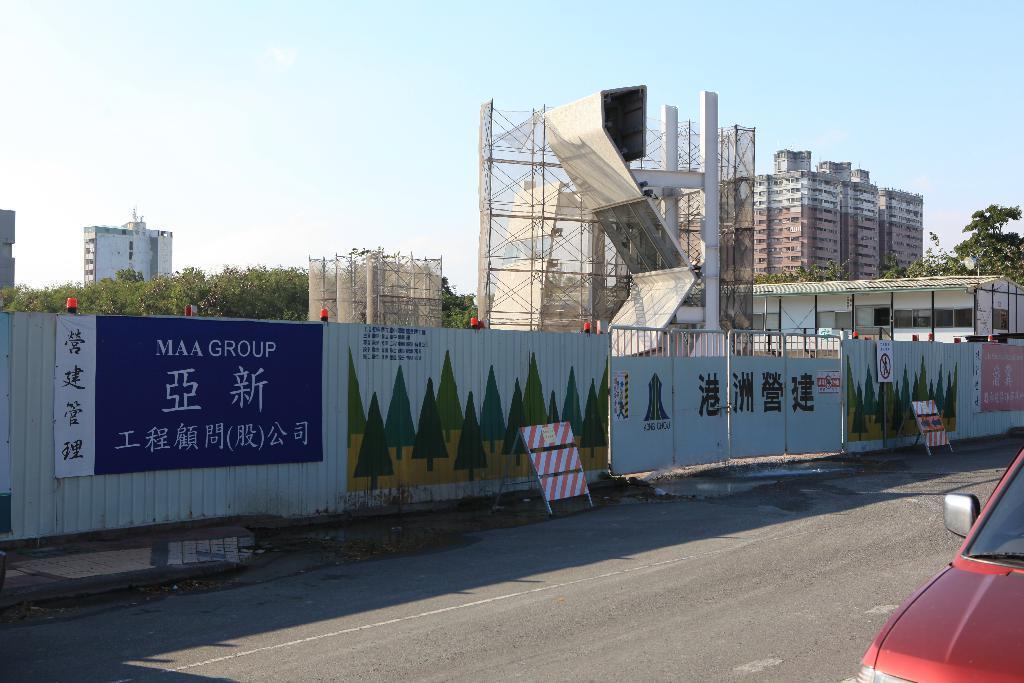Please provide a concise description of this image. There is a vehicle on the road. Here we can see boards, gate, and a wall. In the background there are trees, buildings, and sky. 